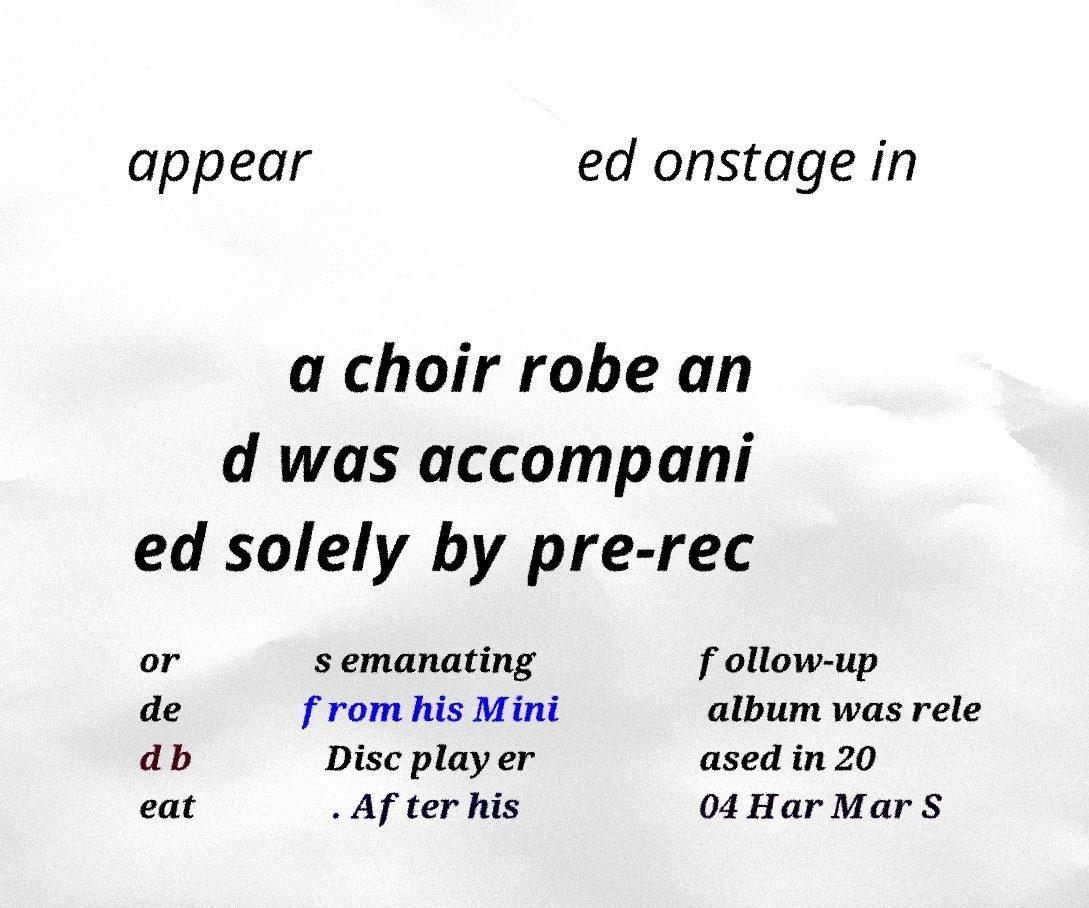There's text embedded in this image that I need extracted. Can you transcribe it verbatim? appear ed onstage in a choir robe an d was accompani ed solely by pre-rec or de d b eat s emanating from his Mini Disc player . After his follow-up album was rele ased in 20 04 Har Mar S 